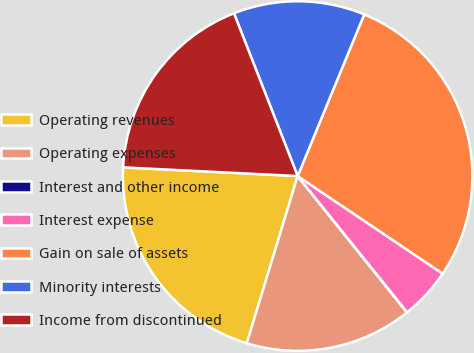Convert chart to OTSL. <chart><loc_0><loc_0><loc_500><loc_500><pie_chart><fcel>Operating revenues<fcel>Operating expenses<fcel>Interest and other income<fcel>Interest expense<fcel>Gain on sale of assets<fcel>Minority interests<fcel>Income from discontinued<nl><fcel>21.09%<fcel>15.45%<fcel>0.03%<fcel>4.79%<fcel>28.21%<fcel>12.15%<fcel>18.27%<nl></chart> 